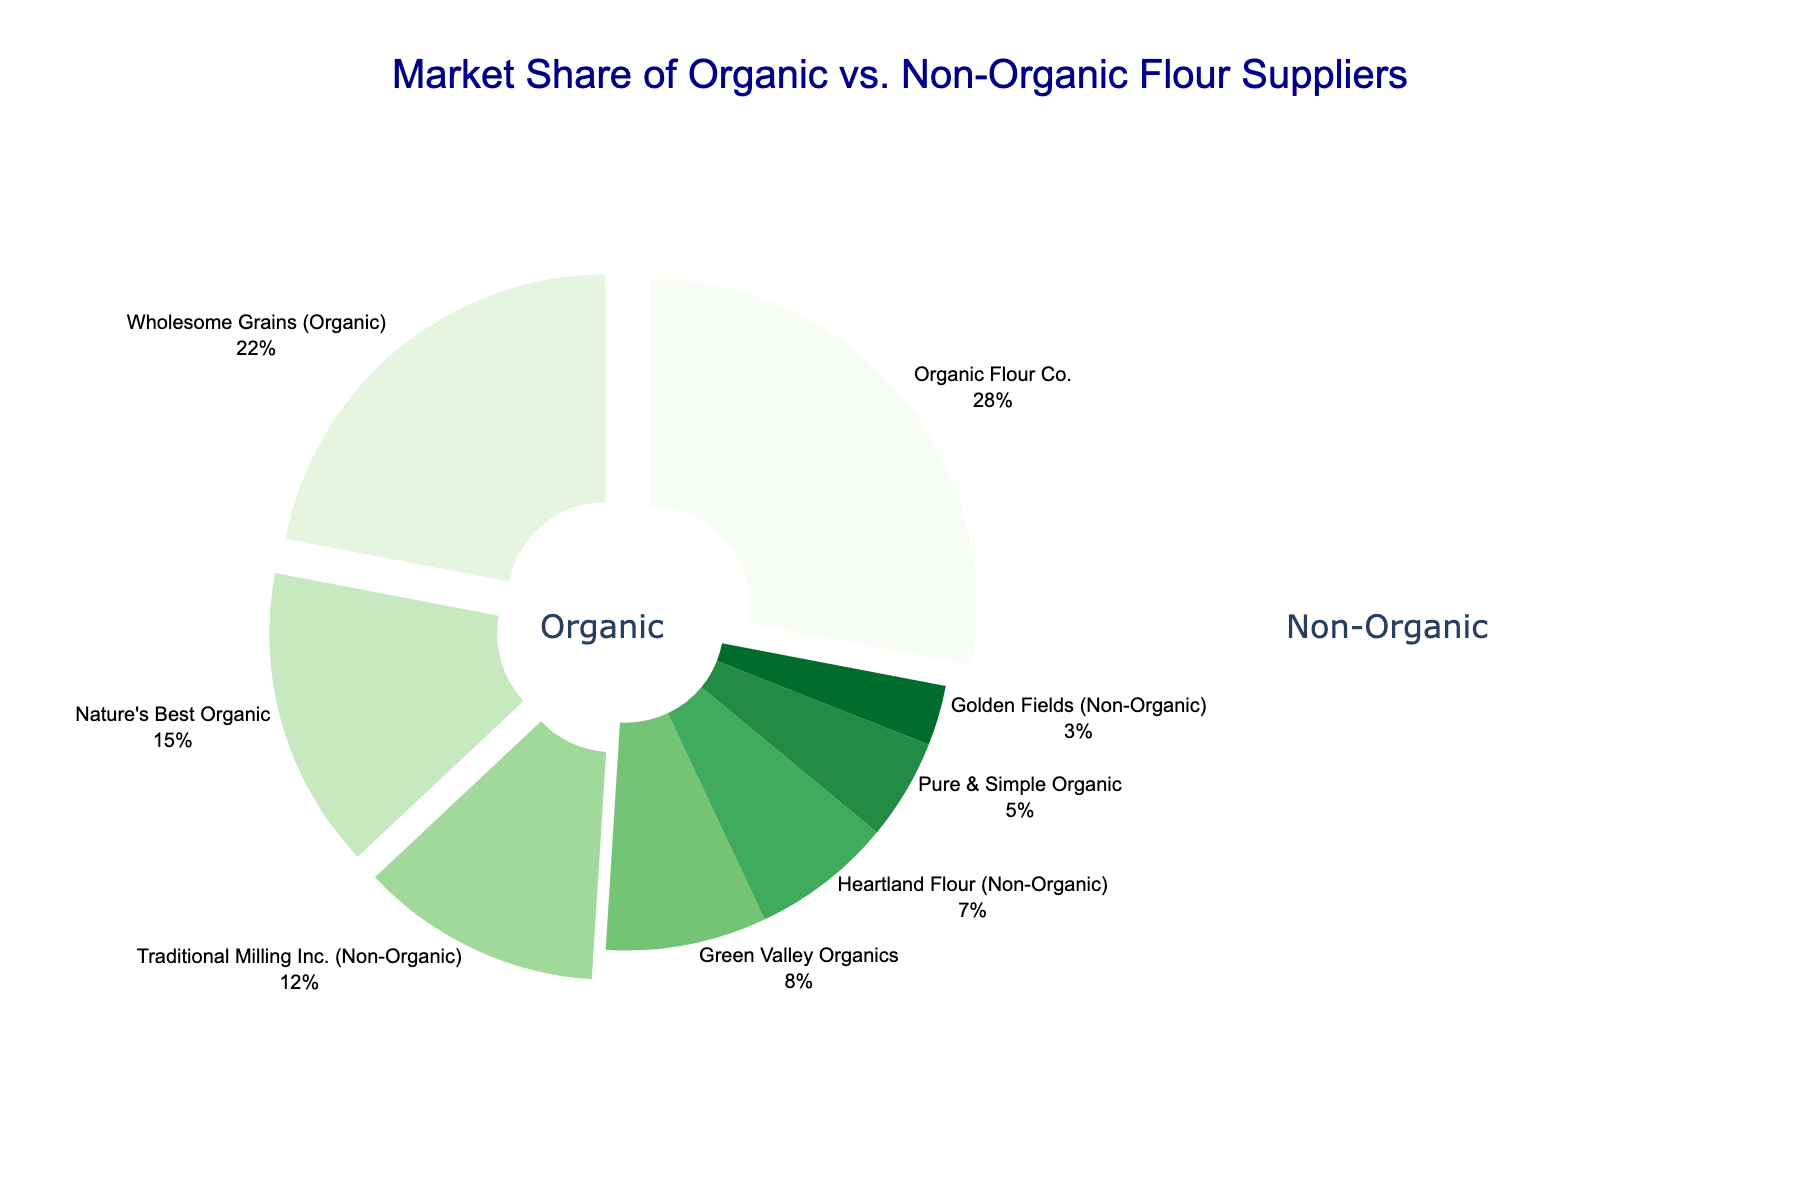what percentage of the market share is controlled by non-organic suppliers? To find the total market share of non-organic suppliers, sum the market share percentages of Traditional Milling Inc. (12%), Heartland Flour (7%), and Golden Fields (3%). The total is 12% + 7% + 3% = 22%.
Answer: 22% How much more market share does Organic Flour Co. have compared to Traditional Milling Inc.? Organic Flour Co. has a 28% market share, while Traditional Milling Inc. has a 12% market share. The difference between them is 28% - 12% = 16%.
Answer: 16% Which supplier has the second-largest market share? By examining the pie chart and the values, Wholesome Grains (Organic) has a 22% market share, which is the second largest after Organic Flour Co. with 28%.
Answer: Wholesome Grains (Organic) Are there more organic or non-organic suppliers, and by how many? Count the suppliers labeled as organic and non-organic. There are 4 organic suppliers (Organic Flour Co., Wholesome Grains, Nature's Best, Green Valley, Pure & Simple) and 3 non-organic suppliers (Traditional Milling, Heartland Flour, Golden Fields). There are 4 - 3 = 1 more organic supplier.
Answer: 1 more organic supplier How much larger is the combined market share of the top two organic suppliers than the combined market share of all non-organic suppliers? The top two organic suppliers are Organic Flour Co. (28%) and Wholesome Grains (22%). Their combined market share is 28% + 22% = 50%. The combined market share of all non-organic suppliers is 12% (Traditional Milling) + 7% (Heartland Flour) + 3% (Golden Fields) = 22%. The difference is 50% - 22% = 28%.
Answer: 28% Which group, organic or non-organic, has a smaller supplier with the smallest market share, and what is it? The smallest market share among organic suppliers is 5% (Pure & Simple Organic). Among non-organic suppliers, the smallest is 3% (Golden Fields). Non-organic has the smallest market share supplier at 3%.
Answer: Non-organic, 3% What percentage more does Wholesome Grains (Organic) have compared to Heartland Flour (Non-Organic)? Wholesome Grains (Organic) has a 22% market share, while Heartland Flour (Non-Organic) has a 7% market share. The difference is 22% - 7% = 15%. To find the percentage more, (15 / 7) * 100 ≈ 214%.
Answer: 214% Which segments on the pie chart are visually larger, organic or non-organic? By observing the pie chart, the segments representing organic labels (greens) appear larger as a group compared to the non-organic labels (reds).
Answer: Organic What is the market share difference between the smallest organic and the smallest non-organic suppliers? The smallest organic supplier is Pure & Simple Organic with a 5% market share. The smallest non-organic supplier is Golden Fields with a 3% market share. The difference is 5% - 3% = 2%.
Answer: 2% Which supplier has a market share that is closest to the average market share of organic suppliers? First, calculate the average market share of organic suppliers: (28% + 22% + 15% + 8% + 5%) / 5 = 78% / 5 = 15.6%. The market share of Nature's Best Organic is 15%, which is closest to this average.
Answer: Nature's Best Organic 